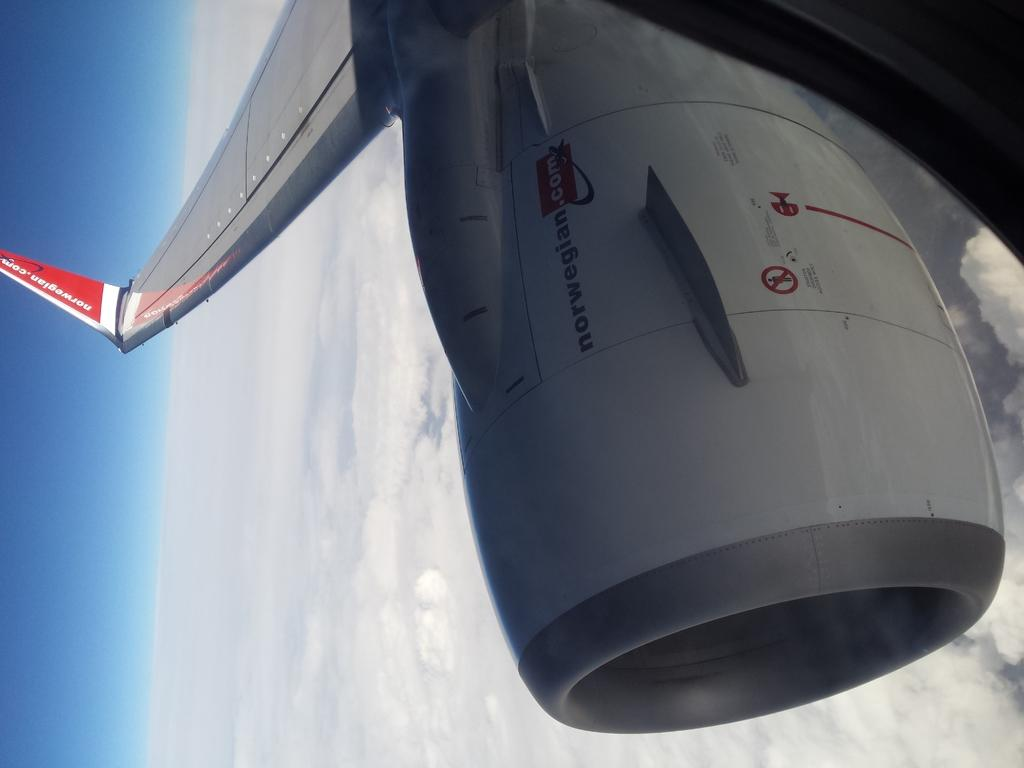<image>
Create a compact narrative representing the image presented. An aircraft of some type is advertising norwegian.com 